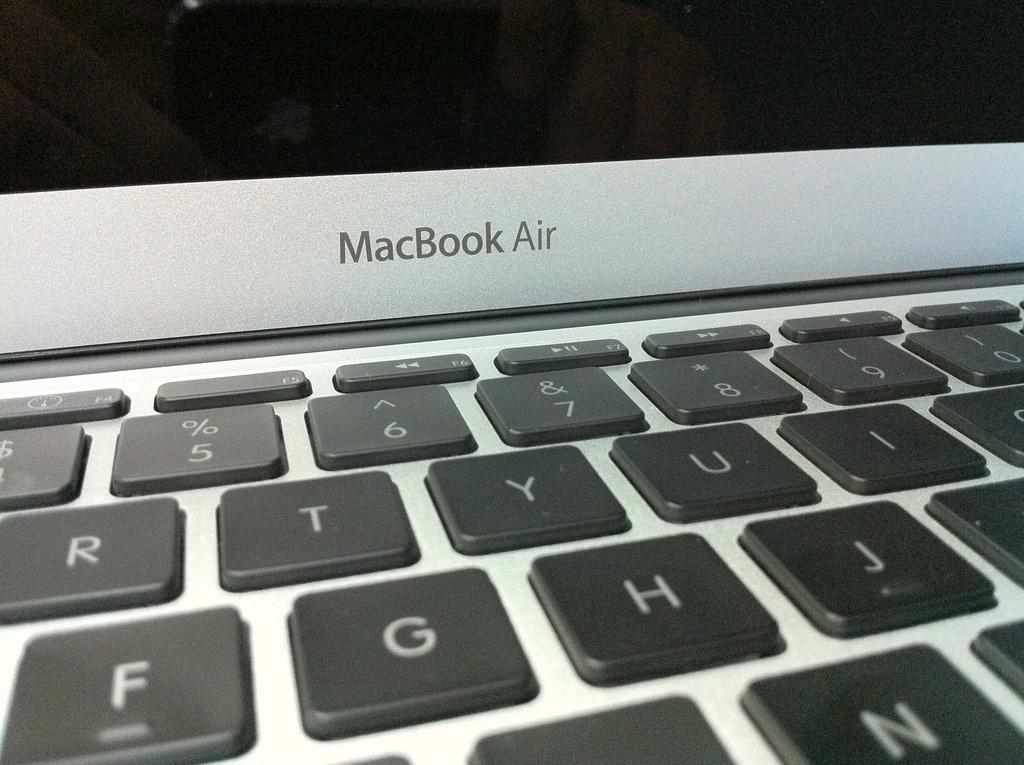<image>
Share a concise interpretation of the image provided. The MacBook Air logo appears above a computer keyboard. 